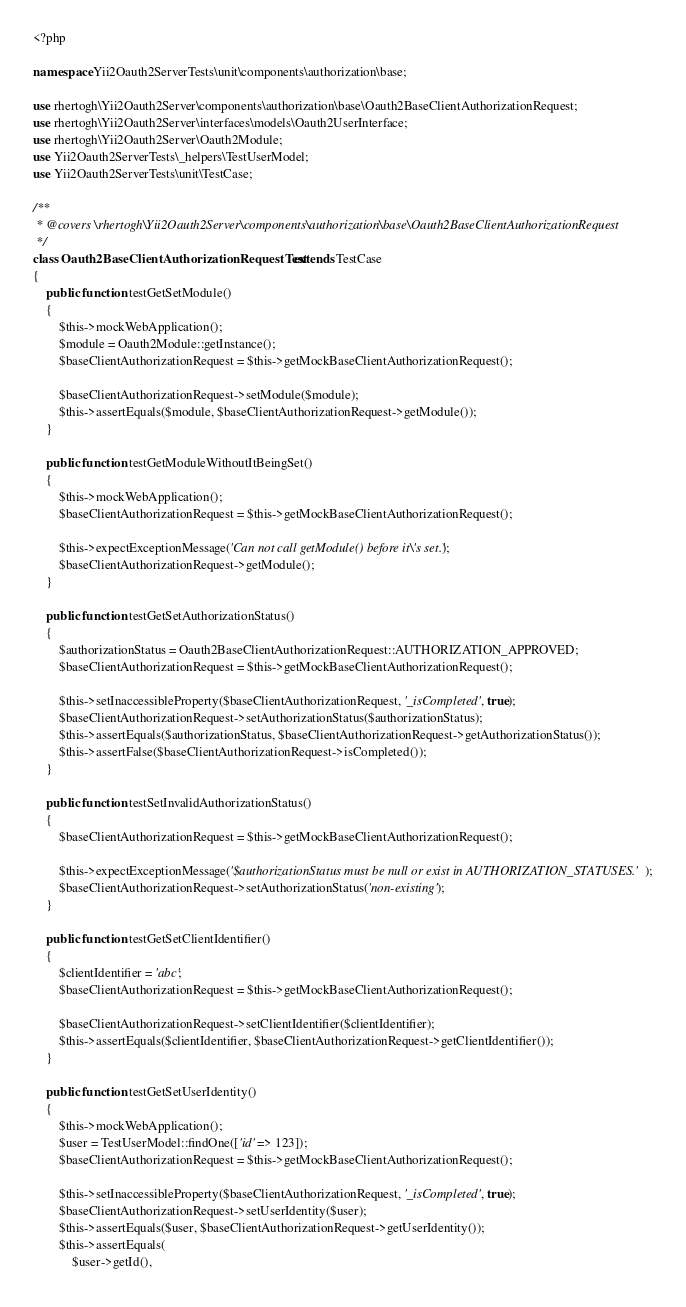<code> <loc_0><loc_0><loc_500><loc_500><_PHP_><?php

namespace Yii2Oauth2ServerTests\unit\components\authorization\base;

use rhertogh\Yii2Oauth2Server\components\authorization\base\Oauth2BaseClientAuthorizationRequest;
use rhertogh\Yii2Oauth2Server\interfaces\models\Oauth2UserInterface;
use rhertogh\Yii2Oauth2Server\Oauth2Module;
use Yii2Oauth2ServerTests\_helpers\TestUserModel;
use Yii2Oauth2ServerTests\unit\TestCase;

/**
 * @covers \rhertogh\Yii2Oauth2Server\components\authorization\base\Oauth2BaseClientAuthorizationRequest
 */
class Oauth2BaseClientAuthorizationRequestTest extends TestCase
{
    public function testGetSetModule()
    {
        $this->mockWebApplication();
        $module = Oauth2Module::getInstance();
        $baseClientAuthorizationRequest = $this->getMockBaseClientAuthorizationRequest();

        $baseClientAuthorizationRequest->setModule($module);
        $this->assertEquals($module, $baseClientAuthorizationRequest->getModule());
    }

    public function testGetModuleWithoutItBeingSet()
    {
        $this->mockWebApplication();
        $baseClientAuthorizationRequest = $this->getMockBaseClientAuthorizationRequest();

        $this->expectExceptionMessage('Can not call getModule() before it\'s set.');
        $baseClientAuthorizationRequest->getModule();
    }

    public function testGetSetAuthorizationStatus()
    {
        $authorizationStatus = Oauth2BaseClientAuthorizationRequest::AUTHORIZATION_APPROVED;
        $baseClientAuthorizationRequest = $this->getMockBaseClientAuthorizationRequest();

        $this->setInaccessibleProperty($baseClientAuthorizationRequest, '_isCompleted', true);
        $baseClientAuthorizationRequest->setAuthorizationStatus($authorizationStatus);
        $this->assertEquals($authorizationStatus, $baseClientAuthorizationRequest->getAuthorizationStatus());
        $this->assertFalse($baseClientAuthorizationRequest->isCompleted());
    }

    public function testSetInvalidAuthorizationStatus()
    {
        $baseClientAuthorizationRequest = $this->getMockBaseClientAuthorizationRequest();

        $this->expectExceptionMessage('$authorizationStatus must be null or exist in AUTHORIZATION_STATUSES.');
        $baseClientAuthorizationRequest->setAuthorizationStatus('non-existing');
    }

    public function testGetSetClientIdentifier()
    {
        $clientIdentifier = 'abc';
        $baseClientAuthorizationRequest = $this->getMockBaseClientAuthorizationRequest();

        $baseClientAuthorizationRequest->setClientIdentifier($clientIdentifier);
        $this->assertEquals($clientIdentifier, $baseClientAuthorizationRequest->getClientIdentifier());
    }

    public function testGetSetUserIdentity()
    {
        $this->mockWebApplication();
        $user = TestUserModel::findOne(['id' => 123]);
        $baseClientAuthorizationRequest = $this->getMockBaseClientAuthorizationRequest();

        $this->setInaccessibleProperty($baseClientAuthorizationRequest, '_isCompleted', true);
        $baseClientAuthorizationRequest->setUserIdentity($user);
        $this->assertEquals($user, $baseClientAuthorizationRequest->getUserIdentity());
        $this->assertEquals(
            $user->getId(),</code> 